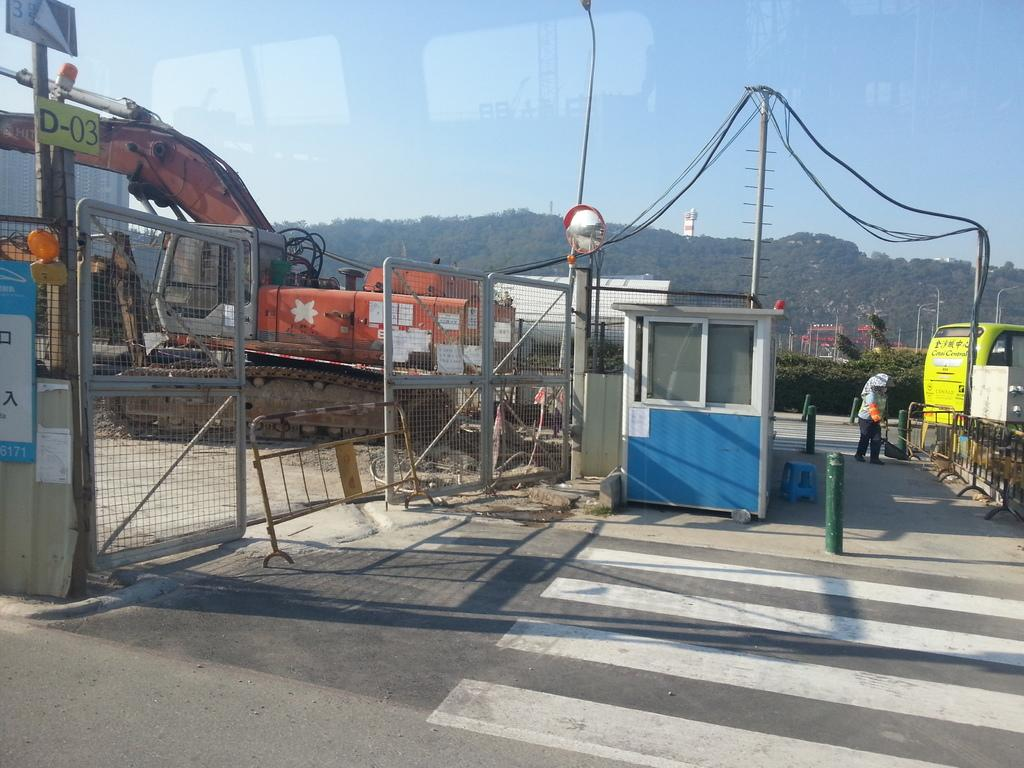What types of objects are present in the image? There are vehicles, a fence, poles, and a road with white color lines in the image. Can you describe the road in the image? The road in the image has white color lines. What can be seen in the background of the image? There are trees and the sky visible in the background of the image. What is the purpose of the poles in the image? The purpose of the poles in the image is not explicitly mentioned, but they could be for supporting wires or signs. How do the ants help in the construction of the fence in the image? There are no ants present in the image, and therefore they cannot help in the construction of the fence. 